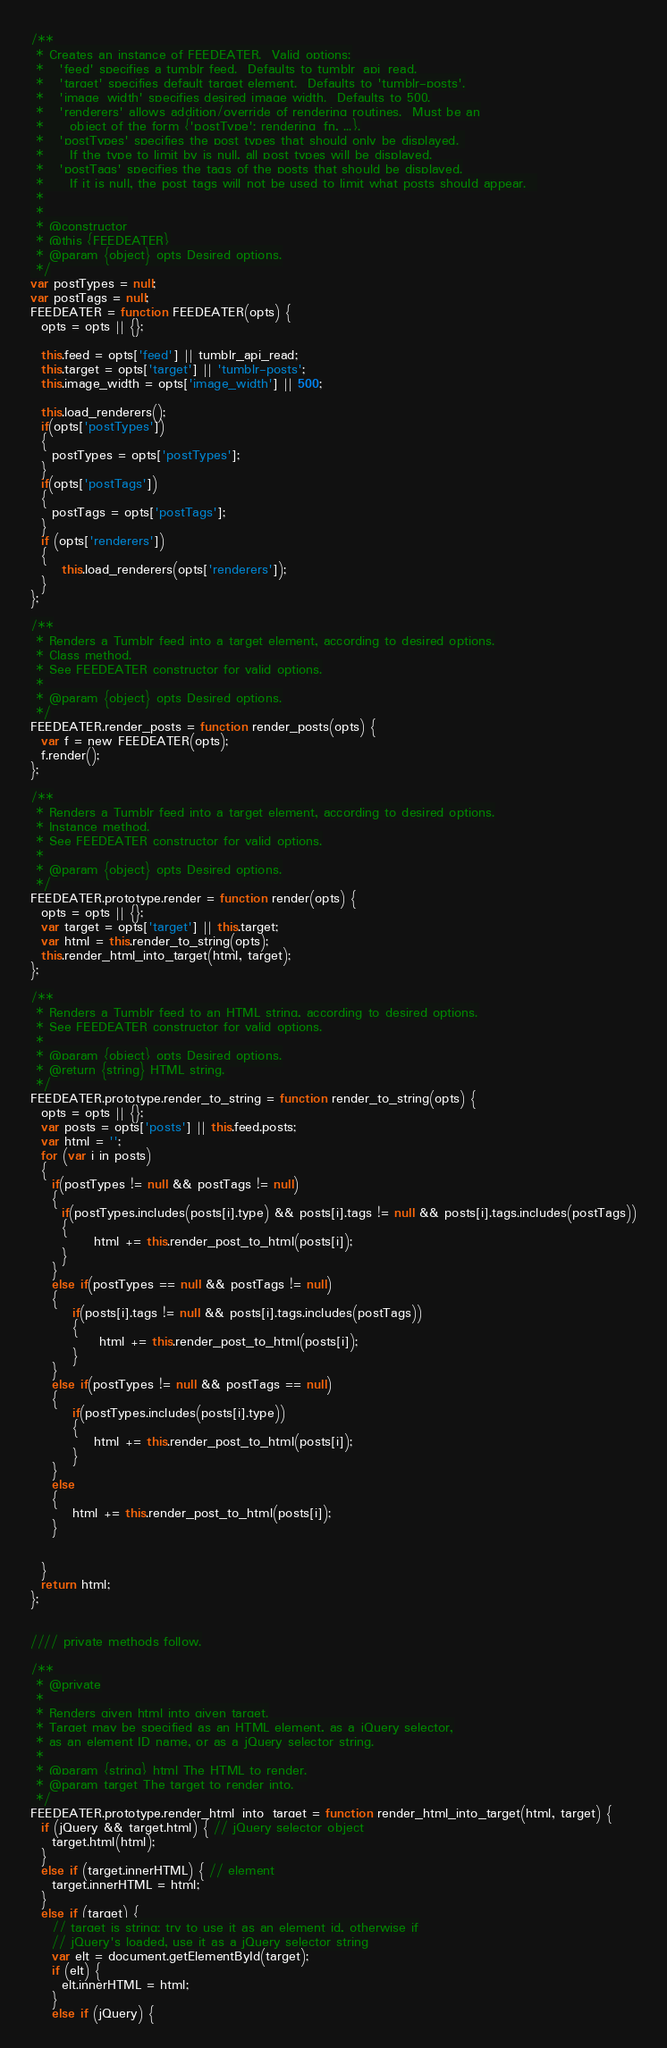<code> <loc_0><loc_0><loc_500><loc_500><_JavaScript_>/**
 * Creates an instance of FEEDEATER.  Valid options:
 *   'feed' specifies a tumblr feed.  Defaults to tumblr_api_read.
 *   'target' specifies default target element.  Defaults to 'tumblr-posts'.
 *   'image_width' specifies desired image width.  Defaults to 500.
 *   'renderers' allows addition/override of rendering routines.  Must be an
 *     object of the form {'postType': rendering_fn, ...}.
 *   'postTypes' specifies the post types that should only be displayed. 
 *     If the type to limit by is null, all post types will be displayed.
 *   'postTags' specifies the tags of the posts that should be displayed.
 *     If it is null, the post tags will not be used to limit what posts should appear.  
 *
 *
 * @constructor
 * @this {FEEDEATER}
 * @param {object} opts Desired options.
 */
var postTypes = null;
var postTags = null;
FEEDEATER = function FEEDEATER(opts) {
  opts = opts || {};

  this.feed = opts['feed'] || tumblr_api_read;
  this.target = opts['target'] || 'tumblr-posts';
  this.image_width = opts['image_width'] || 500;

  this.load_renderers();
  if(opts['postTypes'])
  {
    postTypes = opts['postTypes'];
  }
  if(opts['postTags'])
  {
    postTags = opts['postTags'];
  }
  if (opts['renderers'])
  {
      this.load_renderers(opts['renderers']);
  }
};

/**
 * Renders a Tumblr feed into a target element, according to desired options.
 * Class method.
 * See FEEDEATER constructor for valid options.
 *
 * @param {object} opts Desired options.
 */
FEEDEATER.render_posts = function render_posts(opts) {
  var f = new FEEDEATER(opts);
  f.render();
};

/**
 * Renders a Tumblr feed into a target element, according to desired options.
 * Instance method.
 * See FEEDEATER constructor for valid options.
 *
 * @param {object} opts Desired options.
 */
FEEDEATER.prototype.render = function render(opts) {
  opts = opts || {};
  var target = opts['target'] || this.target;
  var html = this.render_to_string(opts);
  this.render_html_into_target(html, target);
};

/**
 * Renders a Tumblr feed to an HTML string, according to desired options.
 * See FEEDEATER constructor for valid options.
 *
 * @param {object} opts Desired options.
 * @return {string} HTML string.
 */
FEEDEATER.prototype.render_to_string = function render_to_string(opts) {
  opts = opts || {};
  var posts = opts['posts'] || this.feed.posts;
  var html = '';
  for (var i in posts)
  {
    if(postTypes != null && postTags != null)
    {
      if(postTypes.includes(posts[i].type) && posts[i].tags != null && posts[i].tags.includes(postTags))
      {
            html += this.render_post_to_html(posts[i]);
      }
    }
	else if(postTypes == null && postTags != null)
	{
		if(posts[i].tags != null && posts[i].tags.includes(postTags))
		{
			 html += this.render_post_to_html(posts[i]);
		}
	}
	else if(postTypes != null && postTags == null)
	{
		if(postTypes.includes(posts[i].type))
		{
			html += this.render_post_to_html(posts[i]);
		}
	}
    else
    {
        html += this.render_post_to_html(posts[i]);
    }


  }
  return html;
};


//// private methods follow.

/**
 * @private
 *
 * Renders given html into given target.
 * Target may be specified as an HTML element, as a jQuery selector,
 * as an element ID name, or as a jQuery selector string.
 *
 * @param {string} html The HTML to render.
 * @param target The target to render into.
 */
FEEDEATER.prototype.render_html_into_target = function render_html_into_target(html, target) {
  if (jQuery && target.html) { // jQuery selector object
    target.html(html);
  }
  else if (target.innerHTML) { // element
    target.innerHTML = html;
  }
  else if (target) {
    // target is string; try to use it as an element id, otherwise if
    // jQuery's loaded, use it as a jQuery selector string
    var elt = document.getElementById(target);
    if (elt) {
      elt.innerHTML = html;
    }
    else if (jQuery) {</code> 